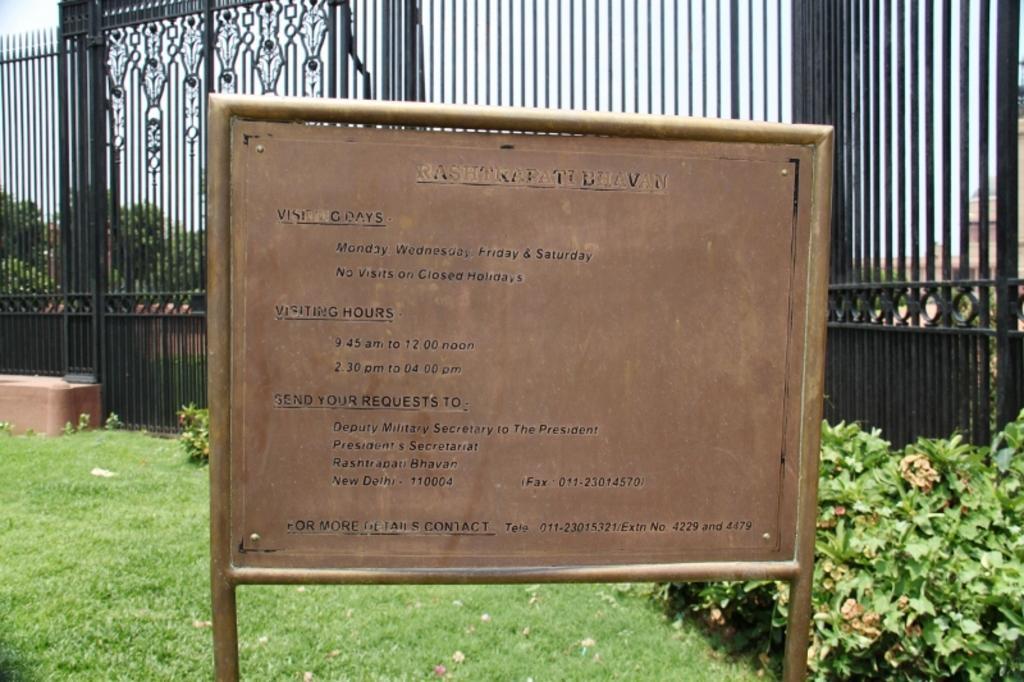Could you give a brief overview of what you see in this image? In this image I can see a board on which something written on it. In the background I can see a fence, plants, the grass, trees and the sky. 